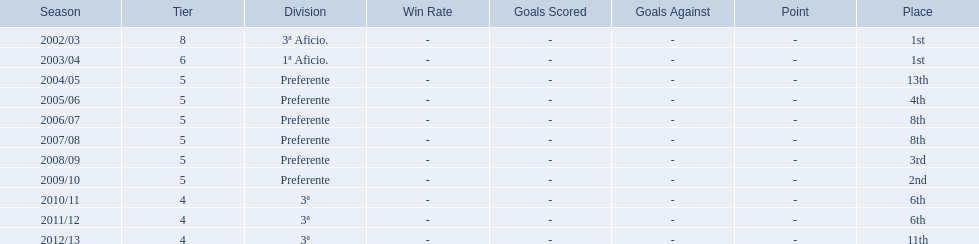How many times did  internacional de madrid cf come in 6th place? 6th, 6th. What is the first season that the team came in 6th place? 2010/11. Which season after the first did they place in 6th again? 2011/12. 